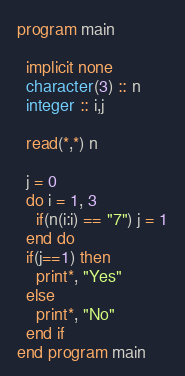Convert code to text. <code><loc_0><loc_0><loc_500><loc_500><_FORTRAN_>program main
  
  implicit none
  character(3) :: n 
  integer :: i,j
  
  read(*,*) n 
   
  j = 0 
  do i = 1, 3
    if(n(i:i) == "7") j = 1
  end do
  if(j==1) then
    print*, "Yes"
  else
    print*, "No"
  end if
end program main
</code> 